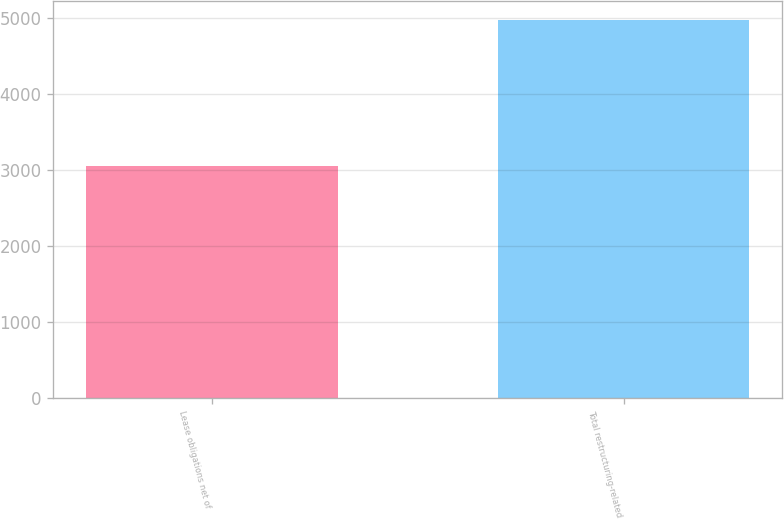Convert chart to OTSL. <chart><loc_0><loc_0><loc_500><loc_500><bar_chart><fcel>Lease obligations net of<fcel>Total restructuring-related<nl><fcel>3057<fcel>4967<nl></chart> 